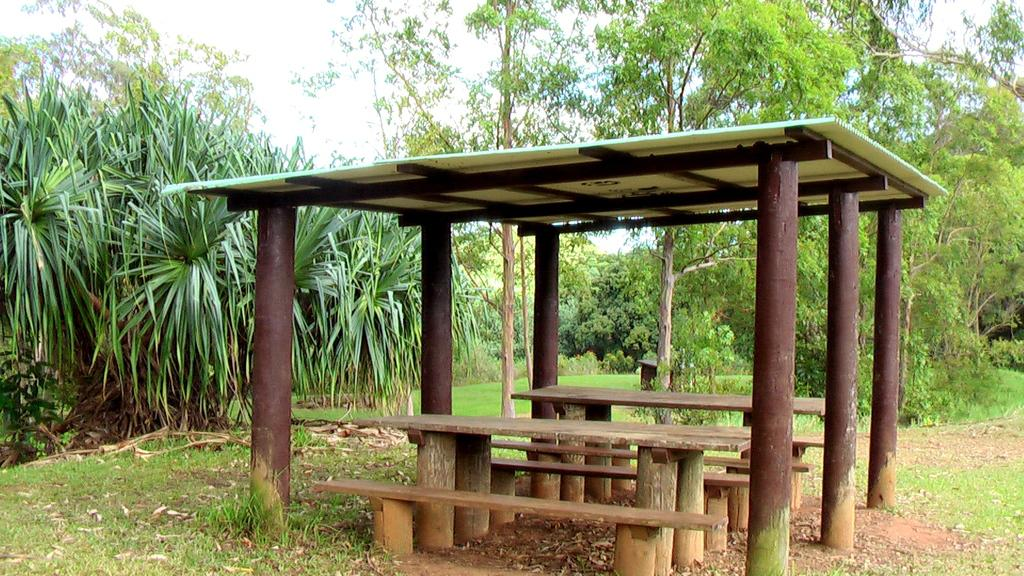What type of structure is in the image? There is a pergola in the image. What type of seating is available in the pergola? There are wooden benches in the pergola. What type of ground surface is visible in the image? There is grass visible in the image. What type of plant material is present on the ground? Dry leaves are present in the image. What can be seen in the background of the image? There are trees and the sky visible in the background of the image. What is the price of the statement made by the tree in the image? There is no statement made by a tree in the image, and therefore no price can be associated with it. 